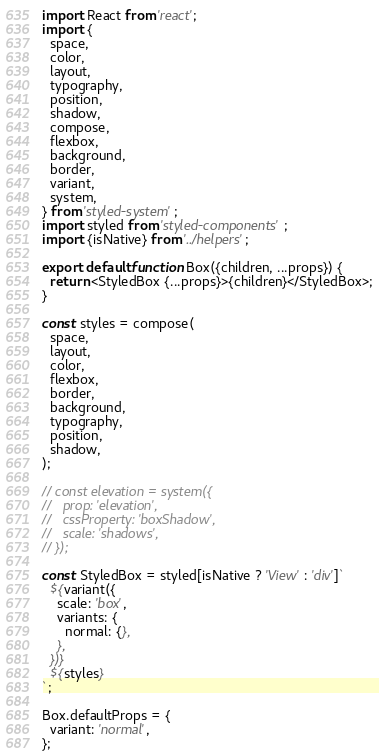Convert code to text. <code><loc_0><loc_0><loc_500><loc_500><_JavaScript_>import React from 'react';
import {
  space,
  color,
  layout,
  typography,
  position,
  shadow,
  compose,
  flexbox,
  background,
  border,
  variant,
  system,
} from 'styled-system';
import styled from 'styled-components';
import {isNative} from '../helpers';

export default function Box({children, ...props}) {
  return <StyledBox {...props}>{children}</StyledBox>;
}

const styles = compose(
  space,
  layout,
  color,
  flexbox,
  border,
  background,
  typography,
  position,
  shadow,
);

// const elevation = system({
//   prop: 'elevation',
//   cssProperty: 'boxShadow',
//   scale: 'shadows',
// });

const StyledBox = styled[isNative ? 'View' : 'div']`
  ${variant({
    scale: 'box',
    variants: {
      normal: {},
    },
  })}
  ${styles}
`;

Box.defaultProps = {
  variant: 'normal',
};
</code> 